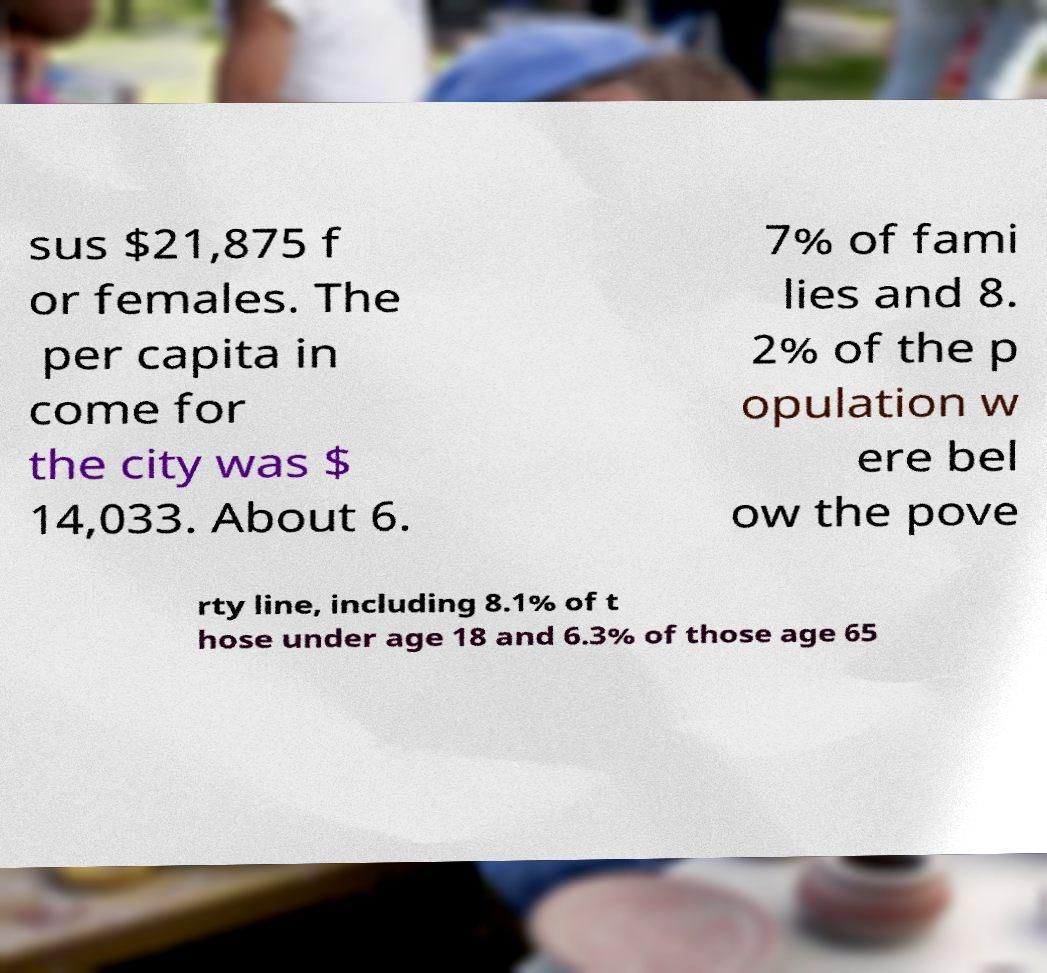What messages or text are displayed in this image? I need them in a readable, typed format. sus $21,875 f or females. The per capita in come for the city was $ 14,033. About 6. 7% of fami lies and 8. 2% of the p opulation w ere bel ow the pove rty line, including 8.1% of t hose under age 18 and 6.3% of those age 65 